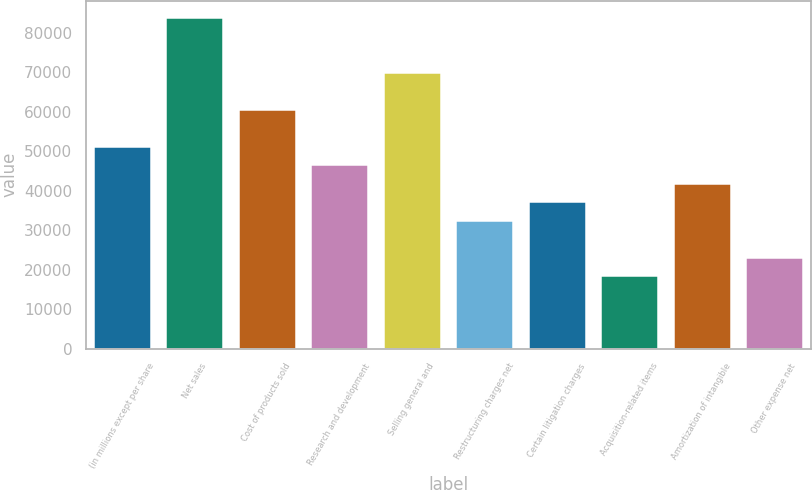Convert chart to OTSL. <chart><loc_0><loc_0><loc_500><loc_500><bar_chart><fcel>(in millions except per share<fcel>Net sales<fcel>Cost of products sold<fcel>Research and development<fcel>Selling general and<fcel>Restructuring charges net<fcel>Certain litigation charges<fcel>Acquisition-related items<fcel>Amortization of intangible<fcel>Other expense net<nl><fcel>51324.8<fcel>83985.4<fcel>60656.4<fcel>46659<fcel>69988<fcel>32661.6<fcel>37327.4<fcel>18664.2<fcel>41993.2<fcel>23330<nl></chart> 